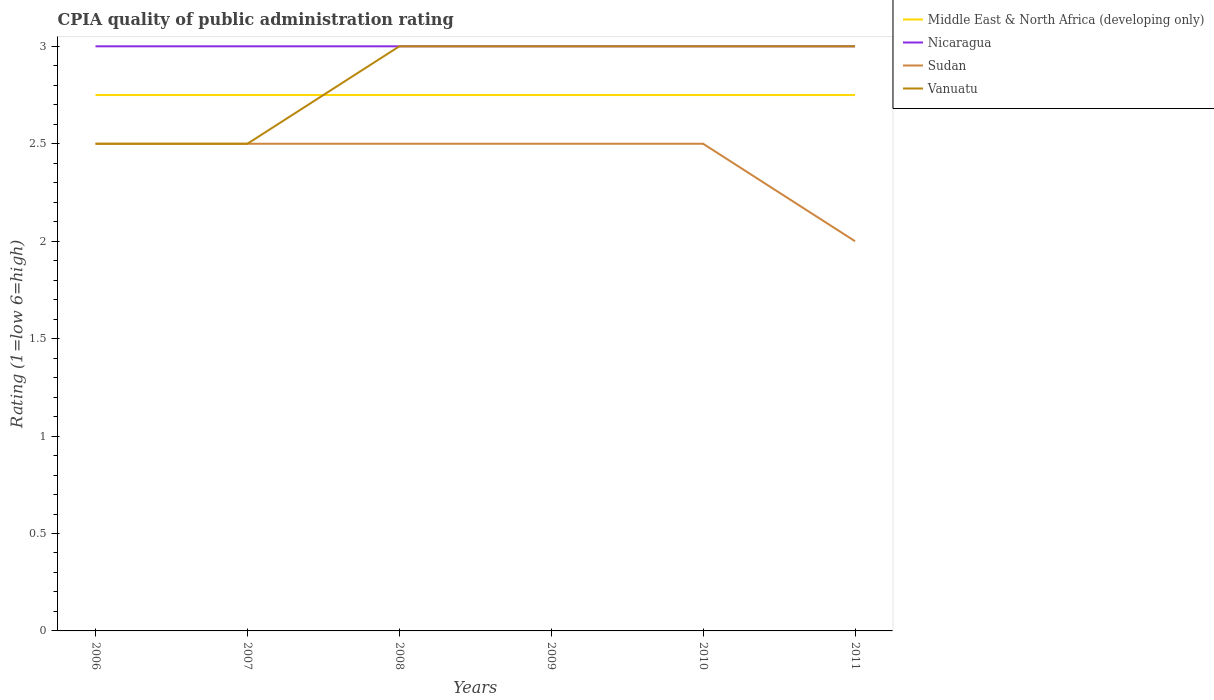How many different coloured lines are there?
Provide a succinct answer. 4. Does the line corresponding to Sudan intersect with the line corresponding to Nicaragua?
Your answer should be very brief. No. Across all years, what is the maximum CPIA rating in Middle East & North Africa (developing only)?
Your answer should be compact. 2.75. What is the total CPIA rating in Nicaragua in the graph?
Your response must be concise. 0. What is the difference between the highest and the second highest CPIA rating in Middle East & North Africa (developing only)?
Give a very brief answer. 0. Are the values on the major ticks of Y-axis written in scientific E-notation?
Offer a terse response. No. Does the graph contain any zero values?
Your answer should be very brief. No. Does the graph contain grids?
Your answer should be compact. No. Where does the legend appear in the graph?
Provide a succinct answer. Top right. How many legend labels are there?
Ensure brevity in your answer.  4. How are the legend labels stacked?
Provide a short and direct response. Vertical. What is the title of the graph?
Your response must be concise. CPIA quality of public administration rating. Does "Cambodia" appear as one of the legend labels in the graph?
Keep it short and to the point. No. What is the label or title of the Y-axis?
Offer a very short reply. Rating (1=low 6=high). What is the Rating (1=low 6=high) in Middle East & North Africa (developing only) in 2006?
Make the answer very short. 2.75. What is the Rating (1=low 6=high) in Nicaragua in 2006?
Keep it short and to the point. 3. What is the Rating (1=low 6=high) in Vanuatu in 2006?
Ensure brevity in your answer.  2.5. What is the Rating (1=low 6=high) in Middle East & North Africa (developing only) in 2007?
Provide a short and direct response. 2.75. What is the Rating (1=low 6=high) in Middle East & North Africa (developing only) in 2008?
Provide a succinct answer. 2.75. What is the Rating (1=low 6=high) of Nicaragua in 2008?
Your answer should be very brief. 3. What is the Rating (1=low 6=high) in Sudan in 2008?
Offer a terse response. 2.5. What is the Rating (1=low 6=high) in Middle East & North Africa (developing only) in 2009?
Provide a short and direct response. 2.75. What is the Rating (1=low 6=high) of Vanuatu in 2009?
Ensure brevity in your answer.  3. What is the Rating (1=low 6=high) in Middle East & North Africa (developing only) in 2010?
Your answer should be very brief. 2.75. What is the Rating (1=low 6=high) of Sudan in 2010?
Offer a terse response. 2.5. What is the Rating (1=low 6=high) in Middle East & North Africa (developing only) in 2011?
Make the answer very short. 2.75. What is the Rating (1=low 6=high) of Nicaragua in 2011?
Ensure brevity in your answer.  3. What is the Rating (1=low 6=high) of Sudan in 2011?
Your answer should be compact. 2. What is the Rating (1=low 6=high) in Vanuatu in 2011?
Offer a very short reply. 3. Across all years, what is the maximum Rating (1=low 6=high) of Middle East & North Africa (developing only)?
Your answer should be compact. 2.75. Across all years, what is the maximum Rating (1=low 6=high) in Nicaragua?
Your response must be concise. 3. Across all years, what is the minimum Rating (1=low 6=high) in Middle East & North Africa (developing only)?
Your answer should be compact. 2.75. Across all years, what is the minimum Rating (1=low 6=high) in Nicaragua?
Provide a succinct answer. 3. Across all years, what is the minimum Rating (1=low 6=high) of Sudan?
Keep it short and to the point. 2. Across all years, what is the minimum Rating (1=low 6=high) of Vanuatu?
Make the answer very short. 2.5. What is the difference between the Rating (1=low 6=high) of Nicaragua in 2006 and that in 2008?
Provide a short and direct response. 0. What is the difference between the Rating (1=low 6=high) of Sudan in 2006 and that in 2008?
Offer a very short reply. 0. What is the difference between the Rating (1=low 6=high) of Middle East & North Africa (developing only) in 2006 and that in 2009?
Offer a very short reply. 0. What is the difference between the Rating (1=low 6=high) of Vanuatu in 2006 and that in 2009?
Ensure brevity in your answer.  -0.5. What is the difference between the Rating (1=low 6=high) of Middle East & North Africa (developing only) in 2006 and that in 2010?
Provide a short and direct response. 0. What is the difference between the Rating (1=low 6=high) in Sudan in 2006 and that in 2010?
Offer a very short reply. 0. What is the difference between the Rating (1=low 6=high) in Vanuatu in 2006 and that in 2010?
Offer a very short reply. -0.5. What is the difference between the Rating (1=low 6=high) in Middle East & North Africa (developing only) in 2006 and that in 2011?
Make the answer very short. 0. What is the difference between the Rating (1=low 6=high) of Nicaragua in 2006 and that in 2011?
Offer a terse response. 0. What is the difference between the Rating (1=low 6=high) in Sudan in 2006 and that in 2011?
Provide a succinct answer. 0.5. What is the difference between the Rating (1=low 6=high) in Vanuatu in 2006 and that in 2011?
Make the answer very short. -0.5. What is the difference between the Rating (1=low 6=high) in Nicaragua in 2007 and that in 2009?
Your response must be concise. 0. What is the difference between the Rating (1=low 6=high) in Sudan in 2007 and that in 2009?
Offer a very short reply. 0. What is the difference between the Rating (1=low 6=high) in Nicaragua in 2007 and that in 2010?
Your answer should be very brief. 0. What is the difference between the Rating (1=low 6=high) of Sudan in 2007 and that in 2010?
Make the answer very short. 0. What is the difference between the Rating (1=low 6=high) in Sudan in 2007 and that in 2011?
Keep it short and to the point. 0.5. What is the difference between the Rating (1=low 6=high) of Vanuatu in 2007 and that in 2011?
Give a very brief answer. -0.5. What is the difference between the Rating (1=low 6=high) of Vanuatu in 2008 and that in 2009?
Keep it short and to the point. 0. What is the difference between the Rating (1=low 6=high) in Middle East & North Africa (developing only) in 2008 and that in 2010?
Your response must be concise. 0. What is the difference between the Rating (1=low 6=high) in Nicaragua in 2008 and that in 2010?
Keep it short and to the point. 0. What is the difference between the Rating (1=low 6=high) in Nicaragua in 2008 and that in 2011?
Offer a terse response. 0. What is the difference between the Rating (1=low 6=high) of Sudan in 2008 and that in 2011?
Keep it short and to the point. 0.5. What is the difference between the Rating (1=low 6=high) of Vanuatu in 2008 and that in 2011?
Offer a very short reply. 0. What is the difference between the Rating (1=low 6=high) in Middle East & North Africa (developing only) in 2009 and that in 2010?
Your answer should be compact. 0. What is the difference between the Rating (1=low 6=high) of Nicaragua in 2009 and that in 2010?
Ensure brevity in your answer.  0. What is the difference between the Rating (1=low 6=high) of Vanuatu in 2009 and that in 2010?
Keep it short and to the point. 0. What is the difference between the Rating (1=low 6=high) of Middle East & North Africa (developing only) in 2009 and that in 2011?
Offer a terse response. 0. What is the difference between the Rating (1=low 6=high) of Nicaragua in 2009 and that in 2011?
Offer a very short reply. 0. What is the difference between the Rating (1=low 6=high) of Nicaragua in 2010 and that in 2011?
Ensure brevity in your answer.  0. What is the difference between the Rating (1=low 6=high) in Sudan in 2010 and that in 2011?
Offer a very short reply. 0.5. What is the difference between the Rating (1=low 6=high) in Middle East & North Africa (developing only) in 2006 and the Rating (1=low 6=high) in Nicaragua in 2007?
Offer a very short reply. -0.25. What is the difference between the Rating (1=low 6=high) of Nicaragua in 2006 and the Rating (1=low 6=high) of Sudan in 2007?
Provide a succinct answer. 0.5. What is the difference between the Rating (1=low 6=high) in Sudan in 2006 and the Rating (1=low 6=high) in Vanuatu in 2007?
Ensure brevity in your answer.  0. What is the difference between the Rating (1=low 6=high) of Middle East & North Africa (developing only) in 2006 and the Rating (1=low 6=high) of Sudan in 2008?
Ensure brevity in your answer.  0.25. What is the difference between the Rating (1=low 6=high) in Middle East & North Africa (developing only) in 2006 and the Rating (1=low 6=high) in Vanuatu in 2008?
Provide a succinct answer. -0.25. What is the difference between the Rating (1=low 6=high) of Nicaragua in 2006 and the Rating (1=low 6=high) of Sudan in 2008?
Make the answer very short. 0.5. What is the difference between the Rating (1=low 6=high) of Nicaragua in 2006 and the Rating (1=low 6=high) of Vanuatu in 2008?
Your answer should be very brief. 0. What is the difference between the Rating (1=low 6=high) of Middle East & North Africa (developing only) in 2006 and the Rating (1=low 6=high) of Nicaragua in 2009?
Offer a terse response. -0.25. What is the difference between the Rating (1=low 6=high) in Middle East & North Africa (developing only) in 2006 and the Rating (1=low 6=high) in Vanuatu in 2009?
Provide a short and direct response. -0.25. What is the difference between the Rating (1=low 6=high) in Nicaragua in 2006 and the Rating (1=low 6=high) in Sudan in 2009?
Your answer should be compact. 0.5. What is the difference between the Rating (1=low 6=high) in Middle East & North Africa (developing only) in 2006 and the Rating (1=low 6=high) in Sudan in 2010?
Provide a short and direct response. 0.25. What is the difference between the Rating (1=low 6=high) in Middle East & North Africa (developing only) in 2006 and the Rating (1=low 6=high) in Vanuatu in 2010?
Provide a short and direct response. -0.25. What is the difference between the Rating (1=low 6=high) in Nicaragua in 2006 and the Rating (1=low 6=high) in Sudan in 2010?
Provide a short and direct response. 0.5. What is the difference between the Rating (1=low 6=high) in Nicaragua in 2006 and the Rating (1=low 6=high) in Sudan in 2011?
Provide a short and direct response. 1. What is the difference between the Rating (1=low 6=high) of Nicaragua in 2006 and the Rating (1=low 6=high) of Vanuatu in 2011?
Offer a terse response. 0. What is the difference between the Rating (1=low 6=high) in Nicaragua in 2007 and the Rating (1=low 6=high) in Vanuatu in 2008?
Offer a very short reply. 0. What is the difference between the Rating (1=low 6=high) in Sudan in 2007 and the Rating (1=low 6=high) in Vanuatu in 2008?
Your answer should be compact. -0.5. What is the difference between the Rating (1=low 6=high) of Middle East & North Africa (developing only) in 2007 and the Rating (1=low 6=high) of Sudan in 2009?
Offer a terse response. 0.25. What is the difference between the Rating (1=low 6=high) in Middle East & North Africa (developing only) in 2007 and the Rating (1=low 6=high) in Vanuatu in 2009?
Provide a short and direct response. -0.25. What is the difference between the Rating (1=low 6=high) in Nicaragua in 2007 and the Rating (1=low 6=high) in Vanuatu in 2009?
Ensure brevity in your answer.  0. What is the difference between the Rating (1=low 6=high) of Middle East & North Africa (developing only) in 2007 and the Rating (1=low 6=high) of Nicaragua in 2010?
Keep it short and to the point. -0.25. What is the difference between the Rating (1=low 6=high) of Middle East & North Africa (developing only) in 2007 and the Rating (1=low 6=high) of Sudan in 2010?
Your answer should be very brief. 0.25. What is the difference between the Rating (1=low 6=high) of Middle East & North Africa (developing only) in 2007 and the Rating (1=low 6=high) of Vanuatu in 2010?
Offer a very short reply. -0.25. What is the difference between the Rating (1=low 6=high) in Nicaragua in 2007 and the Rating (1=low 6=high) in Sudan in 2010?
Give a very brief answer. 0.5. What is the difference between the Rating (1=low 6=high) in Sudan in 2007 and the Rating (1=low 6=high) in Vanuatu in 2010?
Provide a succinct answer. -0.5. What is the difference between the Rating (1=low 6=high) of Middle East & North Africa (developing only) in 2007 and the Rating (1=low 6=high) of Sudan in 2011?
Offer a very short reply. 0.75. What is the difference between the Rating (1=low 6=high) in Nicaragua in 2007 and the Rating (1=low 6=high) in Vanuatu in 2011?
Provide a short and direct response. 0. What is the difference between the Rating (1=low 6=high) in Sudan in 2007 and the Rating (1=low 6=high) in Vanuatu in 2011?
Keep it short and to the point. -0.5. What is the difference between the Rating (1=low 6=high) in Middle East & North Africa (developing only) in 2008 and the Rating (1=low 6=high) in Vanuatu in 2009?
Provide a succinct answer. -0.25. What is the difference between the Rating (1=low 6=high) of Sudan in 2008 and the Rating (1=low 6=high) of Vanuatu in 2009?
Ensure brevity in your answer.  -0.5. What is the difference between the Rating (1=low 6=high) in Middle East & North Africa (developing only) in 2008 and the Rating (1=low 6=high) in Nicaragua in 2010?
Provide a succinct answer. -0.25. What is the difference between the Rating (1=low 6=high) of Middle East & North Africa (developing only) in 2008 and the Rating (1=low 6=high) of Vanuatu in 2010?
Give a very brief answer. -0.25. What is the difference between the Rating (1=low 6=high) in Nicaragua in 2008 and the Rating (1=low 6=high) in Vanuatu in 2010?
Ensure brevity in your answer.  0. What is the difference between the Rating (1=low 6=high) of Middle East & North Africa (developing only) in 2008 and the Rating (1=low 6=high) of Sudan in 2011?
Offer a very short reply. 0.75. What is the difference between the Rating (1=low 6=high) in Nicaragua in 2008 and the Rating (1=low 6=high) in Vanuatu in 2011?
Your answer should be very brief. 0. What is the difference between the Rating (1=low 6=high) of Middle East & North Africa (developing only) in 2009 and the Rating (1=low 6=high) of Sudan in 2010?
Make the answer very short. 0.25. What is the difference between the Rating (1=low 6=high) of Middle East & North Africa (developing only) in 2009 and the Rating (1=low 6=high) of Vanuatu in 2010?
Keep it short and to the point. -0.25. What is the difference between the Rating (1=low 6=high) of Nicaragua in 2009 and the Rating (1=low 6=high) of Sudan in 2010?
Make the answer very short. 0.5. What is the difference between the Rating (1=low 6=high) in Sudan in 2009 and the Rating (1=low 6=high) in Vanuatu in 2010?
Offer a very short reply. -0.5. What is the difference between the Rating (1=low 6=high) in Middle East & North Africa (developing only) in 2009 and the Rating (1=low 6=high) in Nicaragua in 2011?
Make the answer very short. -0.25. What is the difference between the Rating (1=low 6=high) of Middle East & North Africa (developing only) in 2009 and the Rating (1=low 6=high) of Sudan in 2011?
Ensure brevity in your answer.  0.75. What is the difference between the Rating (1=low 6=high) in Middle East & North Africa (developing only) in 2009 and the Rating (1=low 6=high) in Vanuatu in 2011?
Make the answer very short. -0.25. What is the difference between the Rating (1=low 6=high) of Nicaragua in 2009 and the Rating (1=low 6=high) of Sudan in 2011?
Offer a terse response. 1. What is the difference between the Rating (1=low 6=high) of Nicaragua in 2009 and the Rating (1=low 6=high) of Vanuatu in 2011?
Offer a very short reply. 0. What is the difference between the Rating (1=low 6=high) in Middle East & North Africa (developing only) in 2010 and the Rating (1=low 6=high) in Nicaragua in 2011?
Your answer should be very brief. -0.25. What is the difference between the Rating (1=low 6=high) in Nicaragua in 2010 and the Rating (1=low 6=high) in Sudan in 2011?
Make the answer very short. 1. What is the difference between the Rating (1=low 6=high) in Nicaragua in 2010 and the Rating (1=low 6=high) in Vanuatu in 2011?
Offer a very short reply. 0. What is the difference between the Rating (1=low 6=high) in Sudan in 2010 and the Rating (1=low 6=high) in Vanuatu in 2011?
Offer a terse response. -0.5. What is the average Rating (1=low 6=high) in Middle East & North Africa (developing only) per year?
Give a very brief answer. 2.75. What is the average Rating (1=low 6=high) in Nicaragua per year?
Your answer should be compact. 3. What is the average Rating (1=low 6=high) of Sudan per year?
Ensure brevity in your answer.  2.42. What is the average Rating (1=low 6=high) in Vanuatu per year?
Make the answer very short. 2.83. In the year 2006, what is the difference between the Rating (1=low 6=high) in Middle East & North Africa (developing only) and Rating (1=low 6=high) in Sudan?
Keep it short and to the point. 0.25. In the year 2006, what is the difference between the Rating (1=low 6=high) of Sudan and Rating (1=low 6=high) of Vanuatu?
Give a very brief answer. 0. In the year 2007, what is the difference between the Rating (1=low 6=high) of Middle East & North Africa (developing only) and Rating (1=low 6=high) of Sudan?
Give a very brief answer. 0.25. In the year 2007, what is the difference between the Rating (1=low 6=high) in Middle East & North Africa (developing only) and Rating (1=low 6=high) in Vanuatu?
Your response must be concise. 0.25. In the year 2007, what is the difference between the Rating (1=low 6=high) of Nicaragua and Rating (1=low 6=high) of Sudan?
Offer a very short reply. 0.5. In the year 2007, what is the difference between the Rating (1=low 6=high) in Sudan and Rating (1=low 6=high) in Vanuatu?
Provide a short and direct response. 0. In the year 2008, what is the difference between the Rating (1=low 6=high) of Middle East & North Africa (developing only) and Rating (1=low 6=high) of Nicaragua?
Make the answer very short. -0.25. In the year 2008, what is the difference between the Rating (1=low 6=high) of Middle East & North Africa (developing only) and Rating (1=low 6=high) of Sudan?
Your answer should be compact. 0.25. In the year 2008, what is the difference between the Rating (1=low 6=high) in Middle East & North Africa (developing only) and Rating (1=low 6=high) in Vanuatu?
Provide a succinct answer. -0.25. In the year 2008, what is the difference between the Rating (1=low 6=high) of Nicaragua and Rating (1=low 6=high) of Sudan?
Keep it short and to the point. 0.5. In the year 2008, what is the difference between the Rating (1=low 6=high) of Sudan and Rating (1=low 6=high) of Vanuatu?
Your answer should be very brief. -0.5. In the year 2009, what is the difference between the Rating (1=low 6=high) in Nicaragua and Rating (1=low 6=high) in Sudan?
Offer a terse response. 0.5. In the year 2009, what is the difference between the Rating (1=low 6=high) of Nicaragua and Rating (1=low 6=high) of Vanuatu?
Offer a terse response. 0. In the year 2010, what is the difference between the Rating (1=low 6=high) in Middle East & North Africa (developing only) and Rating (1=low 6=high) in Nicaragua?
Make the answer very short. -0.25. In the year 2010, what is the difference between the Rating (1=low 6=high) in Middle East & North Africa (developing only) and Rating (1=low 6=high) in Vanuatu?
Provide a short and direct response. -0.25. In the year 2010, what is the difference between the Rating (1=low 6=high) of Nicaragua and Rating (1=low 6=high) of Sudan?
Make the answer very short. 0.5. In the year 2010, what is the difference between the Rating (1=low 6=high) in Nicaragua and Rating (1=low 6=high) in Vanuatu?
Make the answer very short. 0. In the year 2010, what is the difference between the Rating (1=low 6=high) in Sudan and Rating (1=low 6=high) in Vanuatu?
Provide a succinct answer. -0.5. In the year 2011, what is the difference between the Rating (1=low 6=high) of Middle East & North Africa (developing only) and Rating (1=low 6=high) of Nicaragua?
Your response must be concise. -0.25. In the year 2011, what is the difference between the Rating (1=low 6=high) in Middle East & North Africa (developing only) and Rating (1=low 6=high) in Sudan?
Offer a terse response. 0.75. In the year 2011, what is the difference between the Rating (1=low 6=high) of Nicaragua and Rating (1=low 6=high) of Vanuatu?
Keep it short and to the point. 0. What is the ratio of the Rating (1=low 6=high) in Nicaragua in 2006 to that in 2007?
Keep it short and to the point. 1. What is the ratio of the Rating (1=low 6=high) of Sudan in 2006 to that in 2007?
Provide a succinct answer. 1. What is the ratio of the Rating (1=low 6=high) in Vanuatu in 2006 to that in 2007?
Offer a very short reply. 1. What is the ratio of the Rating (1=low 6=high) of Sudan in 2006 to that in 2008?
Give a very brief answer. 1. What is the ratio of the Rating (1=low 6=high) of Vanuatu in 2006 to that in 2009?
Ensure brevity in your answer.  0.83. What is the ratio of the Rating (1=low 6=high) of Middle East & North Africa (developing only) in 2006 to that in 2010?
Your response must be concise. 1. What is the ratio of the Rating (1=low 6=high) of Nicaragua in 2006 to that in 2010?
Keep it short and to the point. 1. What is the ratio of the Rating (1=low 6=high) of Sudan in 2006 to that in 2010?
Offer a very short reply. 1. What is the ratio of the Rating (1=low 6=high) in Vanuatu in 2006 to that in 2011?
Provide a short and direct response. 0.83. What is the ratio of the Rating (1=low 6=high) of Middle East & North Africa (developing only) in 2007 to that in 2008?
Offer a very short reply. 1. What is the ratio of the Rating (1=low 6=high) of Sudan in 2007 to that in 2008?
Provide a short and direct response. 1. What is the ratio of the Rating (1=low 6=high) in Middle East & North Africa (developing only) in 2007 to that in 2009?
Offer a terse response. 1. What is the ratio of the Rating (1=low 6=high) of Nicaragua in 2007 to that in 2010?
Provide a short and direct response. 1. What is the ratio of the Rating (1=low 6=high) of Vanuatu in 2007 to that in 2010?
Provide a short and direct response. 0.83. What is the ratio of the Rating (1=low 6=high) in Middle East & North Africa (developing only) in 2007 to that in 2011?
Keep it short and to the point. 1. What is the ratio of the Rating (1=low 6=high) in Middle East & North Africa (developing only) in 2008 to that in 2009?
Keep it short and to the point. 1. What is the ratio of the Rating (1=low 6=high) of Middle East & North Africa (developing only) in 2008 to that in 2011?
Make the answer very short. 1. What is the ratio of the Rating (1=low 6=high) of Nicaragua in 2008 to that in 2011?
Provide a short and direct response. 1. What is the ratio of the Rating (1=low 6=high) in Vanuatu in 2008 to that in 2011?
Ensure brevity in your answer.  1. What is the ratio of the Rating (1=low 6=high) in Nicaragua in 2009 to that in 2010?
Provide a succinct answer. 1. What is the ratio of the Rating (1=low 6=high) in Sudan in 2009 to that in 2011?
Your response must be concise. 1.25. What is the ratio of the Rating (1=low 6=high) of Vanuatu in 2009 to that in 2011?
Offer a very short reply. 1. What is the ratio of the Rating (1=low 6=high) of Middle East & North Africa (developing only) in 2010 to that in 2011?
Provide a short and direct response. 1. What is the difference between the highest and the second highest Rating (1=low 6=high) of Middle East & North Africa (developing only)?
Make the answer very short. 0. What is the difference between the highest and the lowest Rating (1=low 6=high) in Sudan?
Offer a very short reply. 0.5. What is the difference between the highest and the lowest Rating (1=low 6=high) in Vanuatu?
Your answer should be very brief. 0.5. 